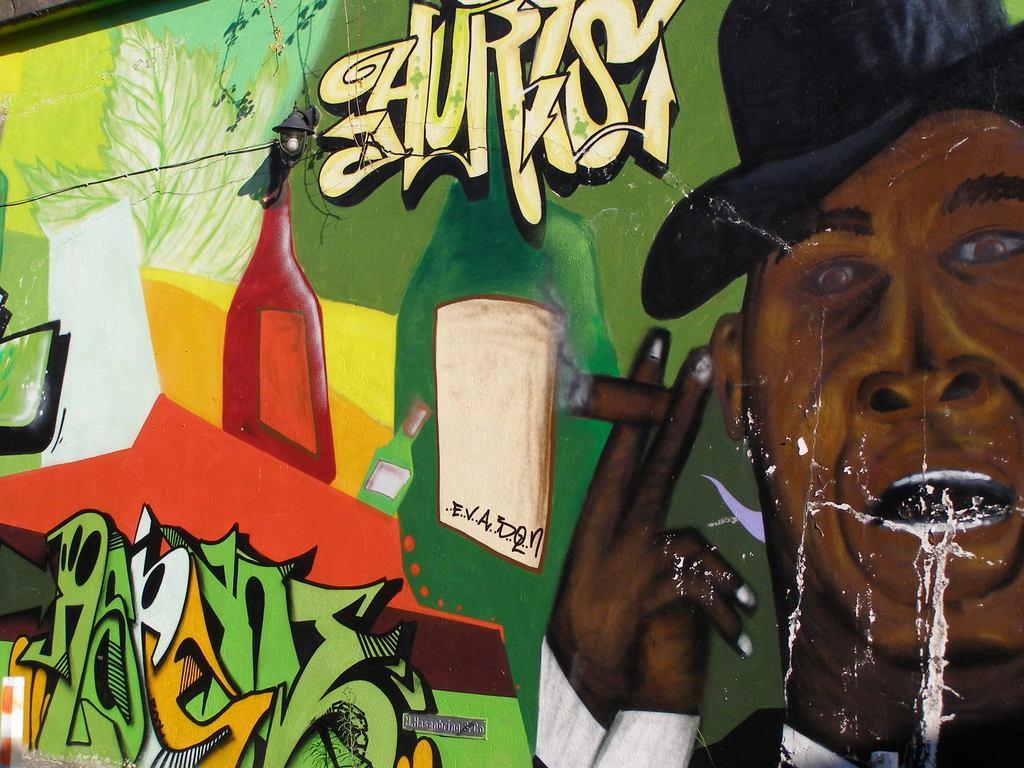Describe this image in one or two sentences. In the image in the center there is a wall. On the wall, we can see some painting, in which we can see a human face, bottles etc. 